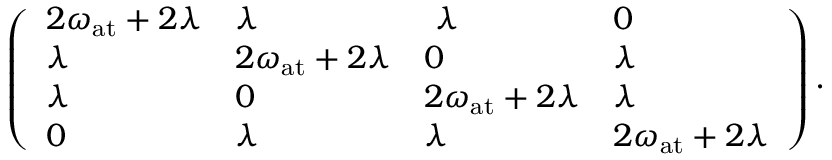<formula> <loc_0><loc_0><loc_500><loc_500>\left ( \begin{array} { l l l l } { 2 \omega _ { a t } + 2 \lambda } & { \lambda } & { \lambda } & { 0 } \\ { \lambda } & { 2 \omega _ { a t } + 2 \lambda } & { 0 } & { \lambda } \\ { \lambda } & { 0 } & { 2 \omega _ { a t } + 2 \lambda } & { \lambda } \\ { 0 } & { \lambda } & { \lambda } & { 2 \omega _ { a t } + 2 \lambda } \end{array} \right ) .</formula> 